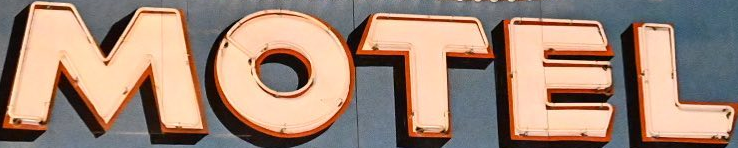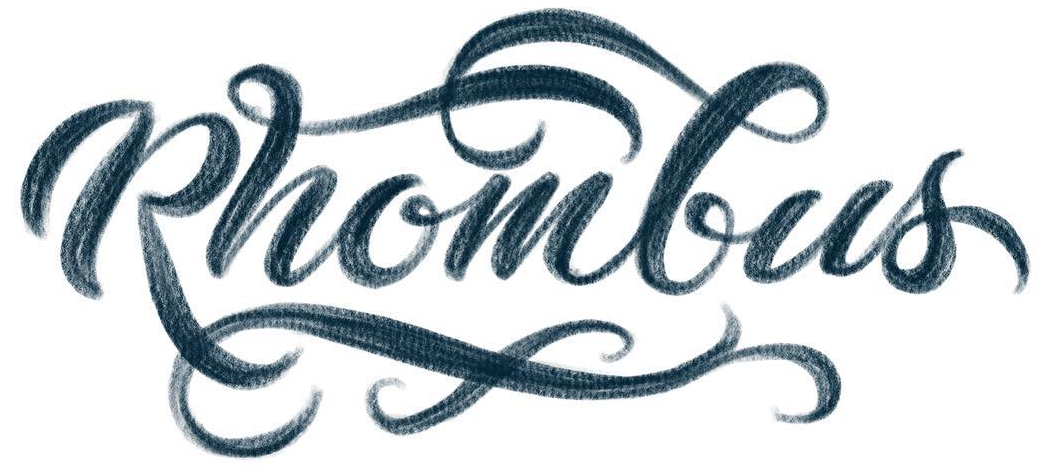Identify the words shown in these images in order, separated by a semicolon. MOTEL; Rhombus 